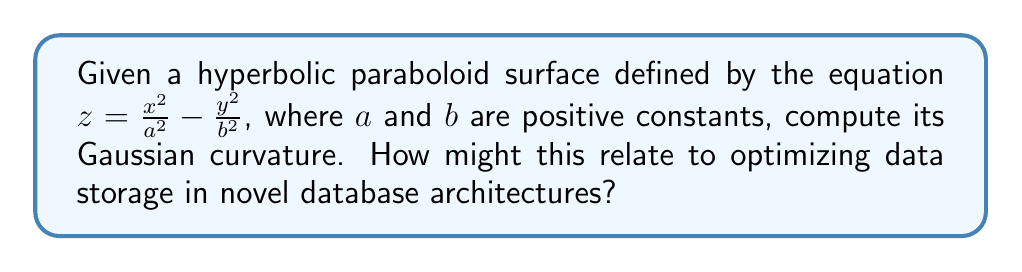Solve this math problem. To compute the Gaussian curvature of the hyperbolic paraboloid, we'll follow these steps:

1) First, we need to calculate the partial derivatives:
   $f_x = \frac{\partial z}{\partial x} = \frac{2x}{a^2}$
   $f_y = \frac{\partial z}{\partial y} = -\frac{2y}{b^2}$
   $f_{xx} = \frac{\partial^2 z}{\partial x^2} = \frac{2}{a^2}$
   $f_{yy} = \frac{\partial^2 z}{\partial y^2} = -\frac{2}{b^2}$
   $f_{xy} = f_{yx} = \frac{\partial^2 z}{\partial x \partial y} = 0$

2) The Gaussian curvature K is given by:
   $$K = \frac{f_{xx}f_{yy} - f_{xy}^2}{(1 + f_x^2 + f_y^2)^2}$$

3) Substituting the values:
   $$K = \frac{(\frac{2}{a^2})(-\frac{2}{b^2}) - 0^2}{(1 + (\frac{2x}{a^2})^2 + (-\frac{2y}{b^2})^2)^2}$$

4) Simplifying:
   $$K = \frac{-\frac{4}{a^2b^2}}{(1 + \frac{4x^2}{a^4} + \frac{4y^2}{b^4})^2}$$

5) This expression gives the Gaussian curvature at any point (x, y) on the surface.

6) Note that K is always negative, which is characteristic of hyperbolic surfaces.

Relating to database architectures: The negative curvature of hyperbolic space allows for exponential growth of area with radius, which could be analogous to how certain database structures might allow for efficient storage and retrieval of expanding datasets. Understanding such geometric properties could inspire novel ways of organizing and accessing data in multidimensional spaces.
Answer: $K = \frac{-\frac{4}{a^2b^2}}{(1 + \frac{4x^2}{a^4} + \frac{4y^2}{b^4})^2}$ 